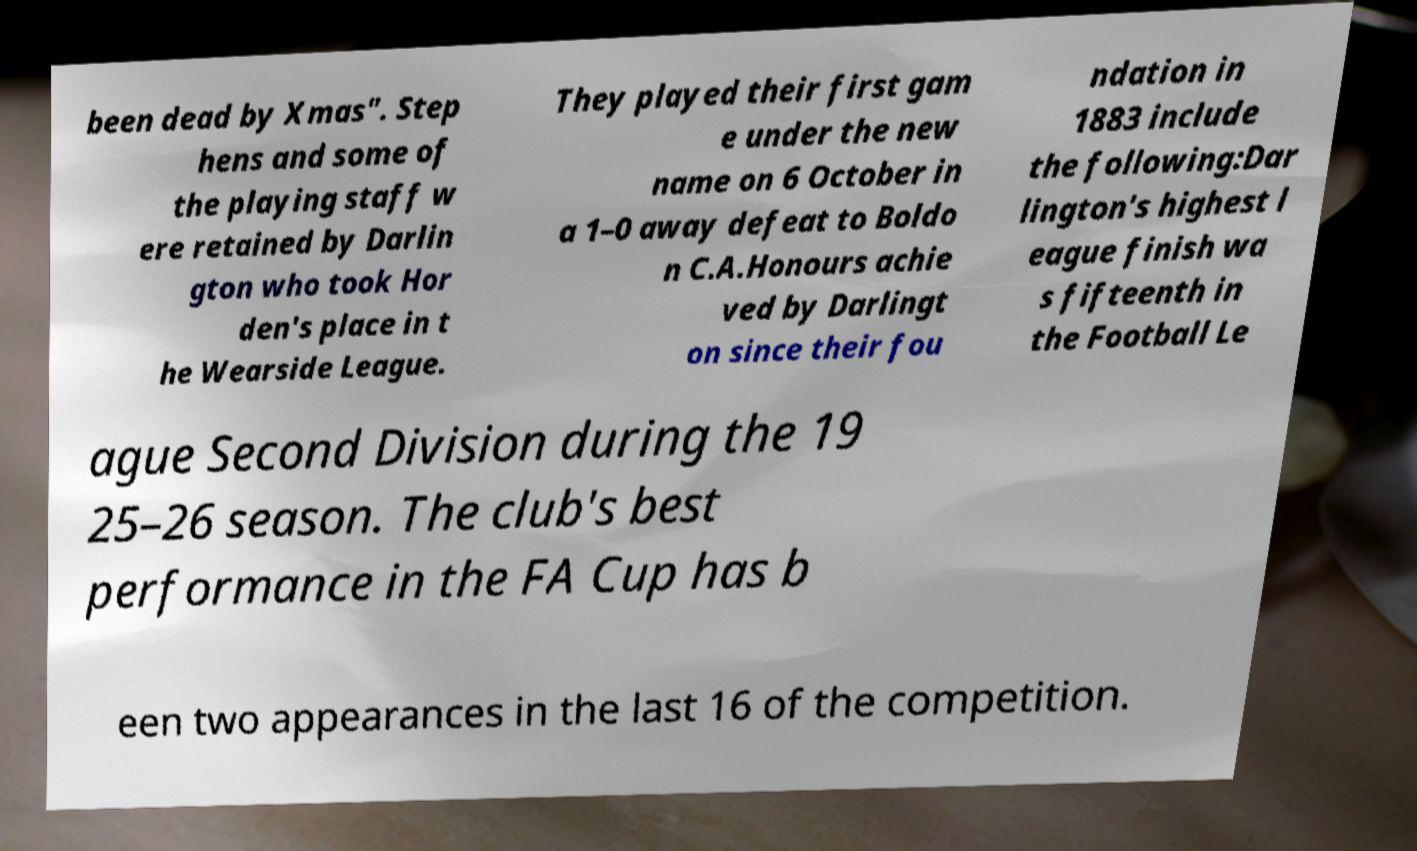What messages or text are displayed in this image? I need them in a readable, typed format. been dead by Xmas". Step hens and some of the playing staff w ere retained by Darlin gton who took Hor den's place in t he Wearside League. They played their first gam e under the new name on 6 October in a 1–0 away defeat to Boldo n C.A.Honours achie ved by Darlingt on since their fou ndation in 1883 include the following:Dar lington's highest l eague finish wa s fifteenth in the Football Le ague Second Division during the 19 25–26 season. The club's best performance in the FA Cup has b een two appearances in the last 16 of the competition. 